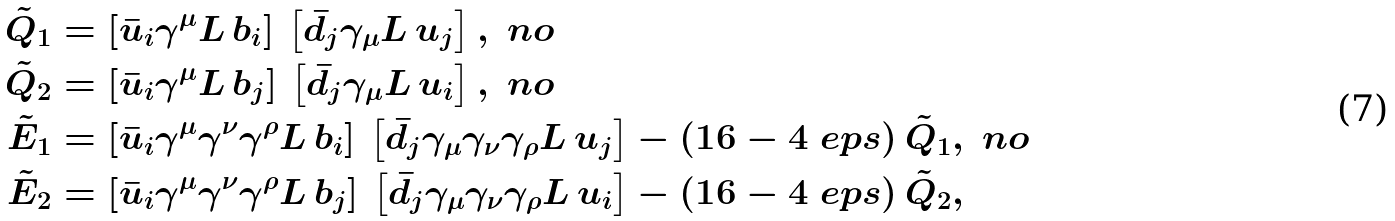Convert formula to latex. <formula><loc_0><loc_0><loc_500><loc_500>\tilde { Q } _ { 1 } & = \left [ \bar { u } _ { i } \gamma ^ { \mu } L \, b _ { i } \right ] \, \left [ \bar { d } _ { j } \gamma _ { \mu } L \, u _ { j } \right ] , \ n o \\ \tilde { Q } _ { 2 } & = \left [ \bar { u } _ { i } \gamma ^ { \mu } L \, b _ { j } \right ] \, \left [ \bar { d } _ { j } \gamma _ { \mu } L \, u _ { i } \right ] , \ n o \\ \tilde { E } _ { 1 } & = \left [ \bar { u } _ { i } \gamma ^ { \mu } \gamma ^ { \nu } \gamma ^ { \rho } L \, b _ { i } \right ] \, \left [ \bar { d } _ { j } \gamma _ { \mu } \gamma _ { \nu } \gamma _ { \rho } L \, u _ { j } \right ] - ( 1 6 - 4 \ e p s ) \, \tilde { Q } _ { 1 } , \ n o \\ \tilde { E } _ { 2 } & = \left [ \bar { u } _ { i } \gamma ^ { \mu } \gamma ^ { \nu } \gamma ^ { \rho } L \, b _ { j } \right ] \, \left [ \bar { d } _ { j } \gamma _ { \mu } \gamma _ { \nu } \gamma _ { \rho } L \, u _ { i } \right ] - ( 1 6 - 4 \ e p s ) \, \tilde { Q } _ { 2 } ,</formula> 